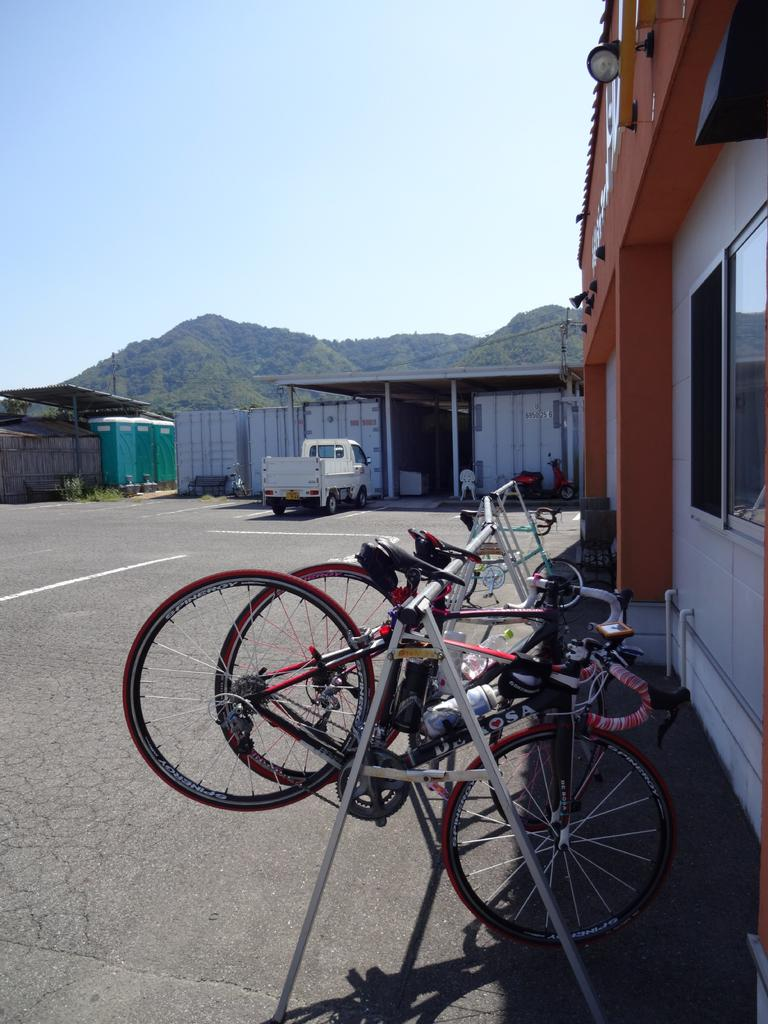What is located in the center of the image? There are bicycles in the center of the image. What can be seen on the right side of the image? There is a house on the right side of the image. What feature of the house is mentioned in the facts? The house has a window. What is visible in the background of the image? There are vehicles, houses, and mountains in the background of the image. Can you see a baseball game happening in the background of the image? There is no mention of a baseball game or any sports activity in the image. What type of leaf is falling from the tree in the image? There is no tree or leaf mentioned in the image. 